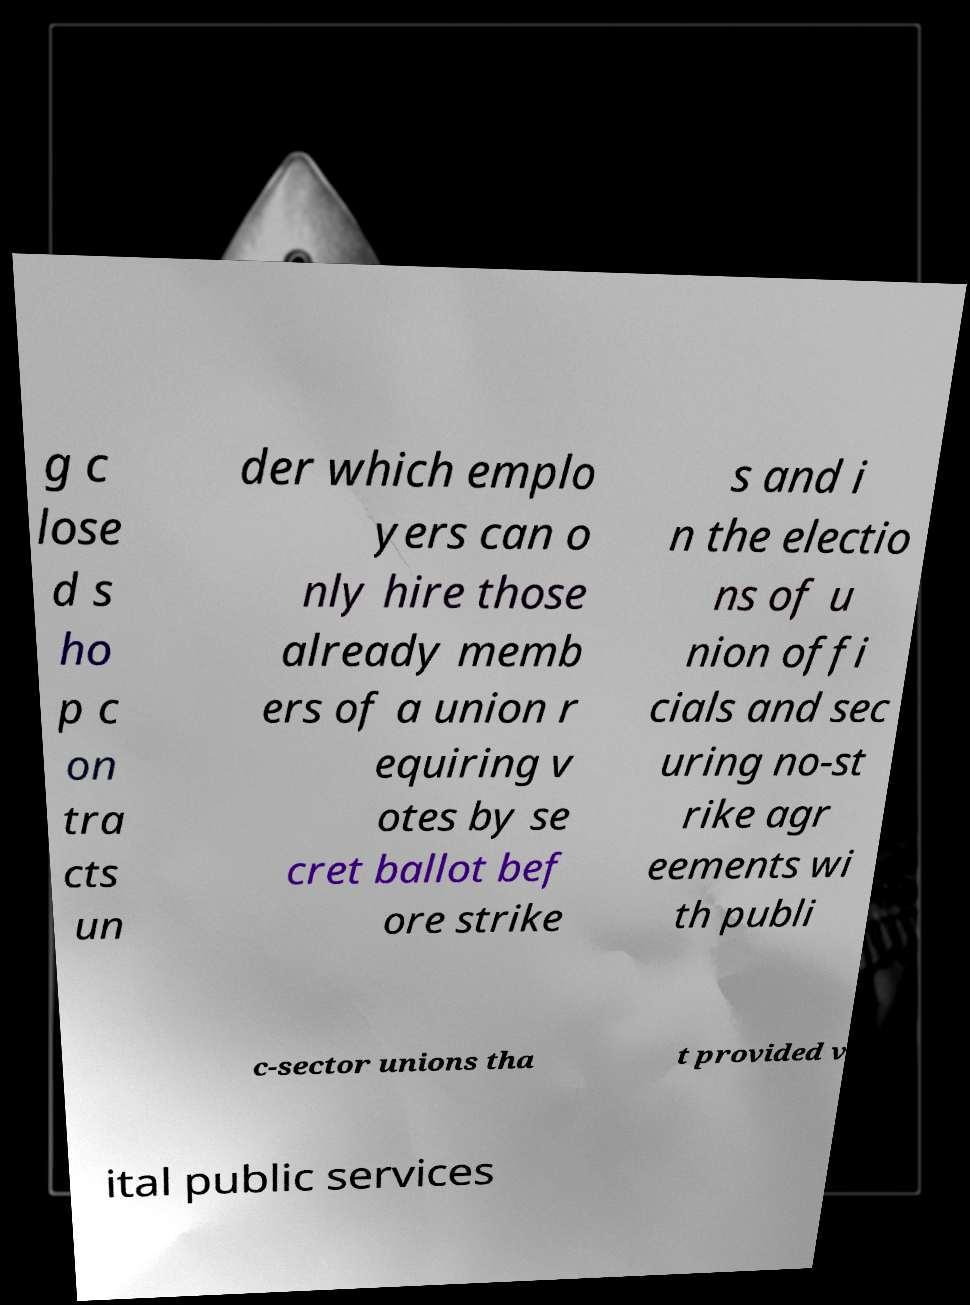Could you assist in decoding the text presented in this image and type it out clearly? g c lose d s ho p c on tra cts un der which emplo yers can o nly hire those already memb ers of a union r equiring v otes by se cret ballot bef ore strike s and i n the electio ns of u nion offi cials and sec uring no-st rike agr eements wi th publi c-sector unions tha t provided v ital public services 